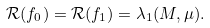Convert formula to latex. <formula><loc_0><loc_0><loc_500><loc_500>\mathcal { R } ( f _ { 0 } ) = \mathcal { R } ( f _ { 1 } ) = \lambda _ { 1 } ( M , \mu ) .</formula> 